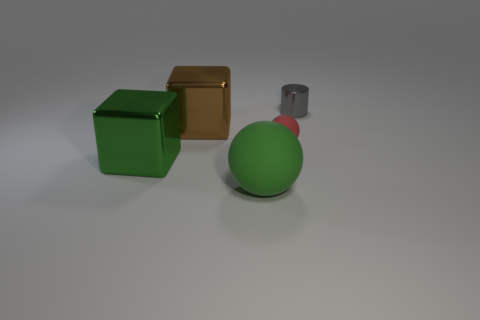Add 2 green metal things. How many objects exist? 7 Subtract all blocks. How many objects are left? 3 Add 5 large metal objects. How many large metal objects exist? 7 Subtract 0 blue cubes. How many objects are left? 5 Subtract all tiny spheres. Subtract all big shiny blocks. How many objects are left? 2 Add 3 shiny objects. How many shiny objects are left? 6 